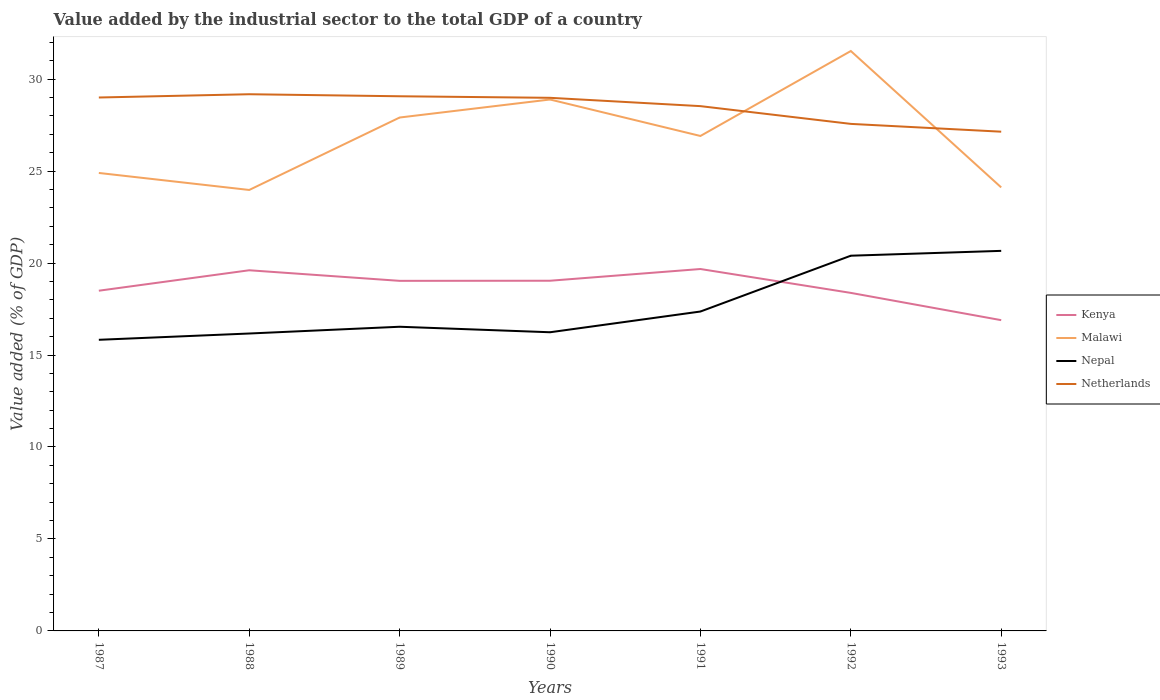How many different coloured lines are there?
Provide a succinct answer. 4. Does the line corresponding to Netherlands intersect with the line corresponding to Kenya?
Offer a terse response. No. Across all years, what is the maximum value added by the industrial sector to the total GDP in Netherlands?
Offer a terse response. 27.14. What is the total value added by the industrial sector to the total GDP in Malawi in the graph?
Provide a succinct answer. 4.78. What is the difference between the highest and the second highest value added by the industrial sector to the total GDP in Kenya?
Provide a succinct answer. 2.78. What is the difference between the highest and the lowest value added by the industrial sector to the total GDP in Netherlands?
Your response must be concise. 5. How many lines are there?
Your answer should be very brief. 4. Are the values on the major ticks of Y-axis written in scientific E-notation?
Make the answer very short. No. Where does the legend appear in the graph?
Offer a terse response. Center right. What is the title of the graph?
Your answer should be compact. Value added by the industrial sector to the total GDP of a country. What is the label or title of the X-axis?
Keep it short and to the point. Years. What is the label or title of the Y-axis?
Offer a very short reply. Value added (% of GDP). What is the Value added (% of GDP) in Kenya in 1987?
Ensure brevity in your answer.  18.49. What is the Value added (% of GDP) of Malawi in 1987?
Offer a terse response. 24.9. What is the Value added (% of GDP) of Nepal in 1987?
Provide a short and direct response. 15.83. What is the Value added (% of GDP) of Netherlands in 1987?
Make the answer very short. 29. What is the Value added (% of GDP) of Kenya in 1988?
Offer a terse response. 19.61. What is the Value added (% of GDP) of Malawi in 1988?
Offer a terse response. 23.97. What is the Value added (% of GDP) of Nepal in 1988?
Ensure brevity in your answer.  16.17. What is the Value added (% of GDP) in Netherlands in 1988?
Provide a short and direct response. 29.18. What is the Value added (% of GDP) in Kenya in 1989?
Your answer should be very brief. 19.03. What is the Value added (% of GDP) in Malawi in 1989?
Ensure brevity in your answer.  27.91. What is the Value added (% of GDP) in Nepal in 1989?
Your response must be concise. 16.54. What is the Value added (% of GDP) of Netherlands in 1989?
Ensure brevity in your answer.  29.07. What is the Value added (% of GDP) in Kenya in 1990?
Offer a very short reply. 19.04. What is the Value added (% of GDP) in Malawi in 1990?
Ensure brevity in your answer.  28.89. What is the Value added (% of GDP) in Nepal in 1990?
Your answer should be very brief. 16.24. What is the Value added (% of GDP) in Netherlands in 1990?
Offer a terse response. 28.98. What is the Value added (% of GDP) in Kenya in 1991?
Your response must be concise. 19.67. What is the Value added (% of GDP) in Malawi in 1991?
Keep it short and to the point. 26.91. What is the Value added (% of GDP) in Nepal in 1991?
Your response must be concise. 17.36. What is the Value added (% of GDP) in Netherlands in 1991?
Ensure brevity in your answer.  28.53. What is the Value added (% of GDP) in Kenya in 1992?
Provide a short and direct response. 18.38. What is the Value added (% of GDP) of Malawi in 1992?
Offer a terse response. 31.53. What is the Value added (% of GDP) in Nepal in 1992?
Your answer should be very brief. 20.4. What is the Value added (% of GDP) in Netherlands in 1992?
Give a very brief answer. 27.56. What is the Value added (% of GDP) of Kenya in 1993?
Provide a succinct answer. 16.89. What is the Value added (% of GDP) in Malawi in 1993?
Your answer should be very brief. 24.11. What is the Value added (% of GDP) in Nepal in 1993?
Provide a short and direct response. 20.66. What is the Value added (% of GDP) of Netherlands in 1993?
Offer a very short reply. 27.14. Across all years, what is the maximum Value added (% of GDP) in Kenya?
Offer a very short reply. 19.67. Across all years, what is the maximum Value added (% of GDP) in Malawi?
Your answer should be very brief. 31.53. Across all years, what is the maximum Value added (% of GDP) of Nepal?
Provide a short and direct response. 20.66. Across all years, what is the maximum Value added (% of GDP) in Netherlands?
Provide a succinct answer. 29.18. Across all years, what is the minimum Value added (% of GDP) in Kenya?
Your response must be concise. 16.89. Across all years, what is the minimum Value added (% of GDP) of Malawi?
Make the answer very short. 23.97. Across all years, what is the minimum Value added (% of GDP) of Nepal?
Provide a short and direct response. 15.83. Across all years, what is the minimum Value added (% of GDP) in Netherlands?
Make the answer very short. 27.14. What is the total Value added (% of GDP) of Kenya in the graph?
Your answer should be very brief. 131.12. What is the total Value added (% of GDP) in Malawi in the graph?
Offer a very short reply. 188.21. What is the total Value added (% of GDP) in Nepal in the graph?
Make the answer very short. 123.19. What is the total Value added (% of GDP) in Netherlands in the graph?
Provide a succinct answer. 199.46. What is the difference between the Value added (% of GDP) of Kenya in 1987 and that in 1988?
Offer a terse response. -1.11. What is the difference between the Value added (% of GDP) of Malawi in 1987 and that in 1988?
Your answer should be very brief. 0.92. What is the difference between the Value added (% of GDP) in Nepal in 1987 and that in 1988?
Offer a terse response. -0.34. What is the difference between the Value added (% of GDP) of Netherlands in 1987 and that in 1988?
Ensure brevity in your answer.  -0.18. What is the difference between the Value added (% of GDP) in Kenya in 1987 and that in 1989?
Provide a succinct answer. -0.54. What is the difference between the Value added (% of GDP) of Malawi in 1987 and that in 1989?
Offer a terse response. -3.01. What is the difference between the Value added (% of GDP) of Nepal in 1987 and that in 1989?
Keep it short and to the point. -0.71. What is the difference between the Value added (% of GDP) in Netherlands in 1987 and that in 1989?
Provide a succinct answer. -0.07. What is the difference between the Value added (% of GDP) of Kenya in 1987 and that in 1990?
Offer a terse response. -0.54. What is the difference between the Value added (% of GDP) in Malawi in 1987 and that in 1990?
Offer a terse response. -3.99. What is the difference between the Value added (% of GDP) in Nepal in 1987 and that in 1990?
Keep it short and to the point. -0.41. What is the difference between the Value added (% of GDP) of Netherlands in 1987 and that in 1990?
Provide a succinct answer. 0.02. What is the difference between the Value added (% of GDP) in Kenya in 1987 and that in 1991?
Your response must be concise. -1.18. What is the difference between the Value added (% of GDP) of Malawi in 1987 and that in 1991?
Keep it short and to the point. -2.01. What is the difference between the Value added (% of GDP) in Nepal in 1987 and that in 1991?
Offer a very short reply. -1.54. What is the difference between the Value added (% of GDP) in Netherlands in 1987 and that in 1991?
Offer a terse response. 0.47. What is the difference between the Value added (% of GDP) of Kenya in 1987 and that in 1992?
Your answer should be compact. 0.12. What is the difference between the Value added (% of GDP) of Malawi in 1987 and that in 1992?
Your answer should be very brief. -6.63. What is the difference between the Value added (% of GDP) of Nepal in 1987 and that in 1992?
Keep it short and to the point. -4.57. What is the difference between the Value added (% of GDP) in Netherlands in 1987 and that in 1992?
Provide a succinct answer. 1.43. What is the difference between the Value added (% of GDP) of Kenya in 1987 and that in 1993?
Give a very brief answer. 1.6. What is the difference between the Value added (% of GDP) in Malawi in 1987 and that in 1993?
Make the answer very short. 0.79. What is the difference between the Value added (% of GDP) of Nepal in 1987 and that in 1993?
Keep it short and to the point. -4.83. What is the difference between the Value added (% of GDP) of Netherlands in 1987 and that in 1993?
Give a very brief answer. 1.86. What is the difference between the Value added (% of GDP) of Kenya in 1988 and that in 1989?
Your response must be concise. 0.58. What is the difference between the Value added (% of GDP) of Malawi in 1988 and that in 1989?
Your answer should be very brief. -3.94. What is the difference between the Value added (% of GDP) in Nepal in 1988 and that in 1989?
Your answer should be very brief. -0.37. What is the difference between the Value added (% of GDP) of Netherlands in 1988 and that in 1989?
Offer a very short reply. 0.11. What is the difference between the Value added (% of GDP) in Kenya in 1988 and that in 1990?
Provide a short and direct response. 0.57. What is the difference between the Value added (% of GDP) in Malawi in 1988 and that in 1990?
Your response must be concise. -4.92. What is the difference between the Value added (% of GDP) of Nepal in 1988 and that in 1990?
Make the answer very short. -0.07. What is the difference between the Value added (% of GDP) in Netherlands in 1988 and that in 1990?
Ensure brevity in your answer.  0.19. What is the difference between the Value added (% of GDP) in Kenya in 1988 and that in 1991?
Provide a short and direct response. -0.07. What is the difference between the Value added (% of GDP) of Malawi in 1988 and that in 1991?
Keep it short and to the point. -2.93. What is the difference between the Value added (% of GDP) of Nepal in 1988 and that in 1991?
Your answer should be compact. -1.19. What is the difference between the Value added (% of GDP) of Netherlands in 1988 and that in 1991?
Ensure brevity in your answer.  0.65. What is the difference between the Value added (% of GDP) of Kenya in 1988 and that in 1992?
Your answer should be very brief. 1.23. What is the difference between the Value added (% of GDP) in Malawi in 1988 and that in 1992?
Make the answer very short. -7.55. What is the difference between the Value added (% of GDP) in Nepal in 1988 and that in 1992?
Offer a terse response. -4.23. What is the difference between the Value added (% of GDP) of Netherlands in 1988 and that in 1992?
Ensure brevity in your answer.  1.61. What is the difference between the Value added (% of GDP) of Kenya in 1988 and that in 1993?
Ensure brevity in your answer.  2.71. What is the difference between the Value added (% of GDP) of Malawi in 1988 and that in 1993?
Your response must be concise. -0.14. What is the difference between the Value added (% of GDP) in Nepal in 1988 and that in 1993?
Your answer should be compact. -4.49. What is the difference between the Value added (% of GDP) in Netherlands in 1988 and that in 1993?
Provide a succinct answer. 2.04. What is the difference between the Value added (% of GDP) in Kenya in 1989 and that in 1990?
Offer a very short reply. -0.01. What is the difference between the Value added (% of GDP) of Malawi in 1989 and that in 1990?
Your answer should be very brief. -0.98. What is the difference between the Value added (% of GDP) of Nepal in 1989 and that in 1990?
Keep it short and to the point. 0.3. What is the difference between the Value added (% of GDP) of Netherlands in 1989 and that in 1990?
Your response must be concise. 0.08. What is the difference between the Value added (% of GDP) of Kenya in 1989 and that in 1991?
Provide a succinct answer. -0.64. What is the difference between the Value added (% of GDP) of Malawi in 1989 and that in 1991?
Offer a terse response. 1. What is the difference between the Value added (% of GDP) of Nepal in 1989 and that in 1991?
Your response must be concise. -0.83. What is the difference between the Value added (% of GDP) of Netherlands in 1989 and that in 1991?
Make the answer very short. 0.54. What is the difference between the Value added (% of GDP) of Kenya in 1989 and that in 1992?
Your answer should be compact. 0.65. What is the difference between the Value added (% of GDP) of Malawi in 1989 and that in 1992?
Make the answer very short. -3.62. What is the difference between the Value added (% of GDP) in Nepal in 1989 and that in 1992?
Provide a succinct answer. -3.86. What is the difference between the Value added (% of GDP) in Netherlands in 1989 and that in 1992?
Offer a very short reply. 1.5. What is the difference between the Value added (% of GDP) of Kenya in 1989 and that in 1993?
Your answer should be very brief. 2.14. What is the difference between the Value added (% of GDP) in Malawi in 1989 and that in 1993?
Offer a terse response. 3.8. What is the difference between the Value added (% of GDP) of Nepal in 1989 and that in 1993?
Provide a short and direct response. -4.13. What is the difference between the Value added (% of GDP) of Netherlands in 1989 and that in 1993?
Provide a short and direct response. 1.93. What is the difference between the Value added (% of GDP) in Kenya in 1990 and that in 1991?
Make the answer very short. -0.64. What is the difference between the Value added (% of GDP) of Malawi in 1990 and that in 1991?
Offer a very short reply. 1.98. What is the difference between the Value added (% of GDP) in Nepal in 1990 and that in 1991?
Provide a short and direct response. -1.13. What is the difference between the Value added (% of GDP) of Netherlands in 1990 and that in 1991?
Your response must be concise. 0.45. What is the difference between the Value added (% of GDP) in Kenya in 1990 and that in 1992?
Provide a succinct answer. 0.66. What is the difference between the Value added (% of GDP) in Malawi in 1990 and that in 1992?
Give a very brief answer. -2.64. What is the difference between the Value added (% of GDP) in Nepal in 1990 and that in 1992?
Keep it short and to the point. -4.16. What is the difference between the Value added (% of GDP) in Netherlands in 1990 and that in 1992?
Your answer should be very brief. 1.42. What is the difference between the Value added (% of GDP) in Kenya in 1990 and that in 1993?
Provide a short and direct response. 2.14. What is the difference between the Value added (% of GDP) in Malawi in 1990 and that in 1993?
Provide a short and direct response. 4.78. What is the difference between the Value added (% of GDP) in Nepal in 1990 and that in 1993?
Keep it short and to the point. -4.42. What is the difference between the Value added (% of GDP) in Netherlands in 1990 and that in 1993?
Provide a succinct answer. 1.84. What is the difference between the Value added (% of GDP) in Kenya in 1991 and that in 1992?
Provide a succinct answer. 1.3. What is the difference between the Value added (% of GDP) in Malawi in 1991 and that in 1992?
Offer a terse response. -4.62. What is the difference between the Value added (% of GDP) in Nepal in 1991 and that in 1992?
Make the answer very short. -3.03. What is the difference between the Value added (% of GDP) of Netherlands in 1991 and that in 1992?
Your answer should be very brief. 0.97. What is the difference between the Value added (% of GDP) of Kenya in 1991 and that in 1993?
Keep it short and to the point. 2.78. What is the difference between the Value added (% of GDP) in Malawi in 1991 and that in 1993?
Your response must be concise. 2.8. What is the difference between the Value added (% of GDP) in Nepal in 1991 and that in 1993?
Make the answer very short. -3.3. What is the difference between the Value added (% of GDP) in Netherlands in 1991 and that in 1993?
Offer a terse response. 1.39. What is the difference between the Value added (% of GDP) in Kenya in 1992 and that in 1993?
Make the answer very short. 1.48. What is the difference between the Value added (% of GDP) of Malawi in 1992 and that in 1993?
Your response must be concise. 7.42. What is the difference between the Value added (% of GDP) in Nepal in 1992 and that in 1993?
Your answer should be compact. -0.26. What is the difference between the Value added (% of GDP) of Netherlands in 1992 and that in 1993?
Make the answer very short. 0.42. What is the difference between the Value added (% of GDP) in Kenya in 1987 and the Value added (% of GDP) in Malawi in 1988?
Offer a very short reply. -5.48. What is the difference between the Value added (% of GDP) in Kenya in 1987 and the Value added (% of GDP) in Nepal in 1988?
Provide a short and direct response. 2.33. What is the difference between the Value added (% of GDP) of Kenya in 1987 and the Value added (% of GDP) of Netherlands in 1988?
Offer a very short reply. -10.68. What is the difference between the Value added (% of GDP) of Malawi in 1987 and the Value added (% of GDP) of Nepal in 1988?
Make the answer very short. 8.73. What is the difference between the Value added (% of GDP) of Malawi in 1987 and the Value added (% of GDP) of Netherlands in 1988?
Provide a succinct answer. -4.28. What is the difference between the Value added (% of GDP) in Nepal in 1987 and the Value added (% of GDP) in Netherlands in 1988?
Your answer should be compact. -13.35. What is the difference between the Value added (% of GDP) of Kenya in 1987 and the Value added (% of GDP) of Malawi in 1989?
Provide a succinct answer. -9.42. What is the difference between the Value added (% of GDP) of Kenya in 1987 and the Value added (% of GDP) of Nepal in 1989?
Your answer should be very brief. 1.96. What is the difference between the Value added (% of GDP) of Kenya in 1987 and the Value added (% of GDP) of Netherlands in 1989?
Offer a very short reply. -10.57. What is the difference between the Value added (% of GDP) of Malawi in 1987 and the Value added (% of GDP) of Nepal in 1989?
Keep it short and to the point. 8.36. What is the difference between the Value added (% of GDP) in Malawi in 1987 and the Value added (% of GDP) in Netherlands in 1989?
Your response must be concise. -4.17. What is the difference between the Value added (% of GDP) of Nepal in 1987 and the Value added (% of GDP) of Netherlands in 1989?
Your answer should be compact. -13.24. What is the difference between the Value added (% of GDP) of Kenya in 1987 and the Value added (% of GDP) of Malawi in 1990?
Your answer should be very brief. -10.4. What is the difference between the Value added (% of GDP) of Kenya in 1987 and the Value added (% of GDP) of Nepal in 1990?
Give a very brief answer. 2.26. What is the difference between the Value added (% of GDP) of Kenya in 1987 and the Value added (% of GDP) of Netherlands in 1990?
Your answer should be very brief. -10.49. What is the difference between the Value added (% of GDP) in Malawi in 1987 and the Value added (% of GDP) in Nepal in 1990?
Give a very brief answer. 8.66. What is the difference between the Value added (% of GDP) in Malawi in 1987 and the Value added (% of GDP) in Netherlands in 1990?
Provide a short and direct response. -4.08. What is the difference between the Value added (% of GDP) in Nepal in 1987 and the Value added (% of GDP) in Netherlands in 1990?
Give a very brief answer. -13.15. What is the difference between the Value added (% of GDP) of Kenya in 1987 and the Value added (% of GDP) of Malawi in 1991?
Offer a very short reply. -8.41. What is the difference between the Value added (% of GDP) of Kenya in 1987 and the Value added (% of GDP) of Nepal in 1991?
Keep it short and to the point. 1.13. What is the difference between the Value added (% of GDP) in Kenya in 1987 and the Value added (% of GDP) in Netherlands in 1991?
Your answer should be compact. -10.03. What is the difference between the Value added (% of GDP) of Malawi in 1987 and the Value added (% of GDP) of Nepal in 1991?
Provide a short and direct response. 7.53. What is the difference between the Value added (% of GDP) in Malawi in 1987 and the Value added (% of GDP) in Netherlands in 1991?
Your answer should be very brief. -3.63. What is the difference between the Value added (% of GDP) in Nepal in 1987 and the Value added (% of GDP) in Netherlands in 1991?
Offer a terse response. -12.7. What is the difference between the Value added (% of GDP) in Kenya in 1987 and the Value added (% of GDP) in Malawi in 1992?
Your answer should be compact. -13.03. What is the difference between the Value added (% of GDP) of Kenya in 1987 and the Value added (% of GDP) of Nepal in 1992?
Offer a very short reply. -1.9. What is the difference between the Value added (% of GDP) of Kenya in 1987 and the Value added (% of GDP) of Netherlands in 1992?
Keep it short and to the point. -9.07. What is the difference between the Value added (% of GDP) in Malawi in 1987 and the Value added (% of GDP) in Nepal in 1992?
Provide a short and direct response. 4.5. What is the difference between the Value added (% of GDP) in Malawi in 1987 and the Value added (% of GDP) in Netherlands in 1992?
Your answer should be very brief. -2.67. What is the difference between the Value added (% of GDP) of Nepal in 1987 and the Value added (% of GDP) of Netherlands in 1992?
Your answer should be compact. -11.74. What is the difference between the Value added (% of GDP) of Kenya in 1987 and the Value added (% of GDP) of Malawi in 1993?
Make the answer very short. -5.62. What is the difference between the Value added (% of GDP) of Kenya in 1987 and the Value added (% of GDP) of Nepal in 1993?
Provide a short and direct response. -2.17. What is the difference between the Value added (% of GDP) of Kenya in 1987 and the Value added (% of GDP) of Netherlands in 1993?
Your response must be concise. -8.65. What is the difference between the Value added (% of GDP) in Malawi in 1987 and the Value added (% of GDP) in Nepal in 1993?
Make the answer very short. 4.24. What is the difference between the Value added (% of GDP) of Malawi in 1987 and the Value added (% of GDP) of Netherlands in 1993?
Your response must be concise. -2.24. What is the difference between the Value added (% of GDP) in Nepal in 1987 and the Value added (% of GDP) in Netherlands in 1993?
Your answer should be compact. -11.31. What is the difference between the Value added (% of GDP) of Kenya in 1988 and the Value added (% of GDP) of Malawi in 1989?
Provide a succinct answer. -8.3. What is the difference between the Value added (% of GDP) in Kenya in 1988 and the Value added (% of GDP) in Nepal in 1989?
Your response must be concise. 3.07. What is the difference between the Value added (% of GDP) in Kenya in 1988 and the Value added (% of GDP) in Netherlands in 1989?
Offer a very short reply. -9.46. What is the difference between the Value added (% of GDP) of Malawi in 1988 and the Value added (% of GDP) of Nepal in 1989?
Your answer should be compact. 7.44. What is the difference between the Value added (% of GDP) of Malawi in 1988 and the Value added (% of GDP) of Netherlands in 1989?
Offer a very short reply. -5.09. What is the difference between the Value added (% of GDP) of Nepal in 1988 and the Value added (% of GDP) of Netherlands in 1989?
Your answer should be compact. -12.9. What is the difference between the Value added (% of GDP) of Kenya in 1988 and the Value added (% of GDP) of Malawi in 1990?
Give a very brief answer. -9.28. What is the difference between the Value added (% of GDP) in Kenya in 1988 and the Value added (% of GDP) in Nepal in 1990?
Keep it short and to the point. 3.37. What is the difference between the Value added (% of GDP) of Kenya in 1988 and the Value added (% of GDP) of Netherlands in 1990?
Ensure brevity in your answer.  -9.38. What is the difference between the Value added (% of GDP) of Malawi in 1988 and the Value added (% of GDP) of Nepal in 1990?
Ensure brevity in your answer.  7.74. What is the difference between the Value added (% of GDP) in Malawi in 1988 and the Value added (% of GDP) in Netherlands in 1990?
Your response must be concise. -5.01. What is the difference between the Value added (% of GDP) in Nepal in 1988 and the Value added (% of GDP) in Netherlands in 1990?
Ensure brevity in your answer.  -12.81. What is the difference between the Value added (% of GDP) in Kenya in 1988 and the Value added (% of GDP) in Malawi in 1991?
Your answer should be very brief. -7.3. What is the difference between the Value added (% of GDP) in Kenya in 1988 and the Value added (% of GDP) in Nepal in 1991?
Give a very brief answer. 2.24. What is the difference between the Value added (% of GDP) of Kenya in 1988 and the Value added (% of GDP) of Netherlands in 1991?
Offer a terse response. -8.92. What is the difference between the Value added (% of GDP) of Malawi in 1988 and the Value added (% of GDP) of Nepal in 1991?
Your answer should be very brief. 6.61. What is the difference between the Value added (% of GDP) of Malawi in 1988 and the Value added (% of GDP) of Netherlands in 1991?
Keep it short and to the point. -4.56. What is the difference between the Value added (% of GDP) of Nepal in 1988 and the Value added (% of GDP) of Netherlands in 1991?
Provide a succinct answer. -12.36. What is the difference between the Value added (% of GDP) in Kenya in 1988 and the Value added (% of GDP) in Malawi in 1992?
Offer a very short reply. -11.92. What is the difference between the Value added (% of GDP) in Kenya in 1988 and the Value added (% of GDP) in Nepal in 1992?
Ensure brevity in your answer.  -0.79. What is the difference between the Value added (% of GDP) in Kenya in 1988 and the Value added (% of GDP) in Netherlands in 1992?
Give a very brief answer. -7.96. What is the difference between the Value added (% of GDP) of Malawi in 1988 and the Value added (% of GDP) of Nepal in 1992?
Your answer should be very brief. 3.57. What is the difference between the Value added (% of GDP) in Malawi in 1988 and the Value added (% of GDP) in Netherlands in 1992?
Your response must be concise. -3.59. What is the difference between the Value added (% of GDP) of Nepal in 1988 and the Value added (% of GDP) of Netherlands in 1992?
Keep it short and to the point. -11.4. What is the difference between the Value added (% of GDP) in Kenya in 1988 and the Value added (% of GDP) in Malawi in 1993?
Make the answer very short. -4.5. What is the difference between the Value added (% of GDP) of Kenya in 1988 and the Value added (% of GDP) of Nepal in 1993?
Your answer should be compact. -1.05. What is the difference between the Value added (% of GDP) in Kenya in 1988 and the Value added (% of GDP) in Netherlands in 1993?
Offer a terse response. -7.53. What is the difference between the Value added (% of GDP) of Malawi in 1988 and the Value added (% of GDP) of Nepal in 1993?
Your answer should be very brief. 3.31. What is the difference between the Value added (% of GDP) of Malawi in 1988 and the Value added (% of GDP) of Netherlands in 1993?
Offer a terse response. -3.17. What is the difference between the Value added (% of GDP) of Nepal in 1988 and the Value added (% of GDP) of Netherlands in 1993?
Make the answer very short. -10.97. What is the difference between the Value added (% of GDP) in Kenya in 1989 and the Value added (% of GDP) in Malawi in 1990?
Provide a succinct answer. -9.86. What is the difference between the Value added (% of GDP) in Kenya in 1989 and the Value added (% of GDP) in Nepal in 1990?
Keep it short and to the point. 2.79. What is the difference between the Value added (% of GDP) in Kenya in 1989 and the Value added (% of GDP) in Netherlands in 1990?
Your answer should be very brief. -9.95. What is the difference between the Value added (% of GDP) of Malawi in 1989 and the Value added (% of GDP) of Nepal in 1990?
Provide a succinct answer. 11.67. What is the difference between the Value added (% of GDP) in Malawi in 1989 and the Value added (% of GDP) in Netherlands in 1990?
Keep it short and to the point. -1.07. What is the difference between the Value added (% of GDP) in Nepal in 1989 and the Value added (% of GDP) in Netherlands in 1990?
Ensure brevity in your answer.  -12.45. What is the difference between the Value added (% of GDP) of Kenya in 1989 and the Value added (% of GDP) of Malawi in 1991?
Make the answer very short. -7.88. What is the difference between the Value added (% of GDP) of Kenya in 1989 and the Value added (% of GDP) of Nepal in 1991?
Ensure brevity in your answer.  1.67. What is the difference between the Value added (% of GDP) of Kenya in 1989 and the Value added (% of GDP) of Netherlands in 1991?
Give a very brief answer. -9.5. What is the difference between the Value added (% of GDP) of Malawi in 1989 and the Value added (% of GDP) of Nepal in 1991?
Your answer should be very brief. 10.55. What is the difference between the Value added (% of GDP) in Malawi in 1989 and the Value added (% of GDP) in Netherlands in 1991?
Give a very brief answer. -0.62. What is the difference between the Value added (% of GDP) in Nepal in 1989 and the Value added (% of GDP) in Netherlands in 1991?
Make the answer very short. -11.99. What is the difference between the Value added (% of GDP) of Kenya in 1989 and the Value added (% of GDP) of Malawi in 1992?
Keep it short and to the point. -12.49. What is the difference between the Value added (% of GDP) in Kenya in 1989 and the Value added (% of GDP) in Nepal in 1992?
Provide a short and direct response. -1.37. What is the difference between the Value added (% of GDP) of Kenya in 1989 and the Value added (% of GDP) of Netherlands in 1992?
Keep it short and to the point. -8.53. What is the difference between the Value added (% of GDP) in Malawi in 1989 and the Value added (% of GDP) in Nepal in 1992?
Offer a terse response. 7.51. What is the difference between the Value added (% of GDP) in Malawi in 1989 and the Value added (% of GDP) in Netherlands in 1992?
Provide a short and direct response. 0.35. What is the difference between the Value added (% of GDP) of Nepal in 1989 and the Value added (% of GDP) of Netherlands in 1992?
Offer a terse response. -11.03. What is the difference between the Value added (% of GDP) of Kenya in 1989 and the Value added (% of GDP) of Malawi in 1993?
Keep it short and to the point. -5.08. What is the difference between the Value added (% of GDP) of Kenya in 1989 and the Value added (% of GDP) of Nepal in 1993?
Your answer should be very brief. -1.63. What is the difference between the Value added (% of GDP) of Kenya in 1989 and the Value added (% of GDP) of Netherlands in 1993?
Give a very brief answer. -8.11. What is the difference between the Value added (% of GDP) in Malawi in 1989 and the Value added (% of GDP) in Nepal in 1993?
Provide a succinct answer. 7.25. What is the difference between the Value added (% of GDP) of Malawi in 1989 and the Value added (% of GDP) of Netherlands in 1993?
Offer a terse response. 0.77. What is the difference between the Value added (% of GDP) in Nepal in 1989 and the Value added (% of GDP) in Netherlands in 1993?
Your response must be concise. -10.6. What is the difference between the Value added (% of GDP) in Kenya in 1990 and the Value added (% of GDP) in Malawi in 1991?
Your response must be concise. -7.87. What is the difference between the Value added (% of GDP) of Kenya in 1990 and the Value added (% of GDP) of Nepal in 1991?
Your answer should be very brief. 1.67. What is the difference between the Value added (% of GDP) in Kenya in 1990 and the Value added (% of GDP) in Netherlands in 1991?
Ensure brevity in your answer.  -9.49. What is the difference between the Value added (% of GDP) of Malawi in 1990 and the Value added (% of GDP) of Nepal in 1991?
Your answer should be compact. 11.53. What is the difference between the Value added (% of GDP) of Malawi in 1990 and the Value added (% of GDP) of Netherlands in 1991?
Keep it short and to the point. 0.36. What is the difference between the Value added (% of GDP) in Nepal in 1990 and the Value added (% of GDP) in Netherlands in 1991?
Make the answer very short. -12.29. What is the difference between the Value added (% of GDP) of Kenya in 1990 and the Value added (% of GDP) of Malawi in 1992?
Offer a terse response. -12.49. What is the difference between the Value added (% of GDP) of Kenya in 1990 and the Value added (% of GDP) of Nepal in 1992?
Make the answer very short. -1.36. What is the difference between the Value added (% of GDP) in Kenya in 1990 and the Value added (% of GDP) in Netherlands in 1992?
Make the answer very short. -8.53. What is the difference between the Value added (% of GDP) of Malawi in 1990 and the Value added (% of GDP) of Nepal in 1992?
Keep it short and to the point. 8.49. What is the difference between the Value added (% of GDP) of Malawi in 1990 and the Value added (% of GDP) of Netherlands in 1992?
Provide a succinct answer. 1.33. What is the difference between the Value added (% of GDP) of Nepal in 1990 and the Value added (% of GDP) of Netherlands in 1992?
Your answer should be very brief. -11.33. What is the difference between the Value added (% of GDP) in Kenya in 1990 and the Value added (% of GDP) in Malawi in 1993?
Ensure brevity in your answer.  -5.07. What is the difference between the Value added (% of GDP) of Kenya in 1990 and the Value added (% of GDP) of Nepal in 1993?
Keep it short and to the point. -1.62. What is the difference between the Value added (% of GDP) in Kenya in 1990 and the Value added (% of GDP) in Netherlands in 1993?
Give a very brief answer. -8.1. What is the difference between the Value added (% of GDP) in Malawi in 1990 and the Value added (% of GDP) in Nepal in 1993?
Your answer should be compact. 8.23. What is the difference between the Value added (% of GDP) of Malawi in 1990 and the Value added (% of GDP) of Netherlands in 1993?
Make the answer very short. 1.75. What is the difference between the Value added (% of GDP) in Nepal in 1990 and the Value added (% of GDP) in Netherlands in 1993?
Ensure brevity in your answer.  -10.9. What is the difference between the Value added (% of GDP) in Kenya in 1991 and the Value added (% of GDP) in Malawi in 1992?
Keep it short and to the point. -11.85. What is the difference between the Value added (% of GDP) in Kenya in 1991 and the Value added (% of GDP) in Nepal in 1992?
Your answer should be very brief. -0.72. What is the difference between the Value added (% of GDP) of Kenya in 1991 and the Value added (% of GDP) of Netherlands in 1992?
Your answer should be very brief. -7.89. What is the difference between the Value added (% of GDP) of Malawi in 1991 and the Value added (% of GDP) of Nepal in 1992?
Give a very brief answer. 6.51. What is the difference between the Value added (% of GDP) in Malawi in 1991 and the Value added (% of GDP) in Netherlands in 1992?
Your response must be concise. -0.66. What is the difference between the Value added (% of GDP) in Nepal in 1991 and the Value added (% of GDP) in Netherlands in 1992?
Your answer should be very brief. -10.2. What is the difference between the Value added (% of GDP) in Kenya in 1991 and the Value added (% of GDP) in Malawi in 1993?
Your answer should be very brief. -4.44. What is the difference between the Value added (% of GDP) of Kenya in 1991 and the Value added (% of GDP) of Nepal in 1993?
Provide a short and direct response. -0.99. What is the difference between the Value added (% of GDP) of Kenya in 1991 and the Value added (% of GDP) of Netherlands in 1993?
Make the answer very short. -7.47. What is the difference between the Value added (% of GDP) in Malawi in 1991 and the Value added (% of GDP) in Nepal in 1993?
Keep it short and to the point. 6.25. What is the difference between the Value added (% of GDP) in Malawi in 1991 and the Value added (% of GDP) in Netherlands in 1993?
Your response must be concise. -0.23. What is the difference between the Value added (% of GDP) of Nepal in 1991 and the Value added (% of GDP) of Netherlands in 1993?
Your answer should be compact. -9.78. What is the difference between the Value added (% of GDP) in Kenya in 1992 and the Value added (% of GDP) in Malawi in 1993?
Keep it short and to the point. -5.73. What is the difference between the Value added (% of GDP) in Kenya in 1992 and the Value added (% of GDP) in Nepal in 1993?
Provide a succinct answer. -2.28. What is the difference between the Value added (% of GDP) of Kenya in 1992 and the Value added (% of GDP) of Netherlands in 1993?
Make the answer very short. -8.76. What is the difference between the Value added (% of GDP) in Malawi in 1992 and the Value added (% of GDP) in Nepal in 1993?
Provide a short and direct response. 10.86. What is the difference between the Value added (% of GDP) in Malawi in 1992 and the Value added (% of GDP) in Netherlands in 1993?
Provide a short and direct response. 4.39. What is the difference between the Value added (% of GDP) in Nepal in 1992 and the Value added (% of GDP) in Netherlands in 1993?
Keep it short and to the point. -6.74. What is the average Value added (% of GDP) in Kenya per year?
Make the answer very short. 18.73. What is the average Value added (% of GDP) of Malawi per year?
Provide a short and direct response. 26.89. What is the average Value added (% of GDP) in Nepal per year?
Provide a short and direct response. 17.6. What is the average Value added (% of GDP) of Netherlands per year?
Provide a succinct answer. 28.49. In the year 1987, what is the difference between the Value added (% of GDP) in Kenya and Value added (% of GDP) in Malawi?
Your answer should be very brief. -6.4. In the year 1987, what is the difference between the Value added (% of GDP) of Kenya and Value added (% of GDP) of Nepal?
Keep it short and to the point. 2.67. In the year 1987, what is the difference between the Value added (% of GDP) of Kenya and Value added (% of GDP) of Netherlands?
Your response must be concise. -10.5. In the year 1987, what is the difference between the Value added (% of GDP) in Malawi and Value added (% of GDP) in Nepal?
Offer a very short reply. 9.07. In the year 1987, what is the difference between the Value added (% of GDP) in Malawi and Value added (% of GDP) in Netherlands?
Make the answer very short. -4.1. In the year 1987, what is the difference between the Value added (% of GDP) in Nepal and Value added (% of GDP) in Netherlands?
Keep it short and to the point. -13.17. In the year 1988, what is the difference between the Value added (% of GDP) of Kenya and Value added (% of GDP) of Malawi?
Your response must be concise. -4.37. In the year 1988, what is the difference between the Value added (% of GDP) of Kenya and Value added (% of GDP) of Nepal?
Your answer should be very brief. 3.44. In the year 1988, what is the difference between the Value added (% of GDP) in Kenya and Value added (% of GDP) in Netherlands?
Your answer should be very brief. -9.57. In the year 1988, what is the difference between the Value added (% of GDP) of Malawi and Value added (% of GDP) of Nepal?
Your response must be concise. 7.8. In the year 1988, what is the difference between the Value added (% of GDP) in Malawi and Value added (% of GDP) in Netherlands?
Provide a short and direct response. -5.2. In the year 1988, what is the difference between the Value added (% of GDP) of Nepal and Value added (% of GDP) of Netherlands?
Keep it short and to the point. -13.01. In the year 1989, what is the difference between the Value added (% of GDP) of Kenya and Value added (% of GDP) of Malawi?
Your answer should be very brief. -8.88. In the year 1989, what is the difference between the Value added (% of GDP) of Kenya and Value added (% of GDP) of Nepal?
Give a very brief answer. 2.5. In the year 1989, what is the difference between the Value added (% of GDP) of Kenya and Value added (% of GDP) of Netherlands?
Offer a very short reply. -10.03. In the year 1989, what is the difference between the Value added (% of GDP) of Malawi and Value added (% of GDP) of Nepal?
Your response must be concise. 11.37. In the year 1989, what is the difference between the Value added (% of GDP) of Malawi and Value added (% of GDP) of Netherlands?
Your answer should be very brief. -1.16. In the year 1989, what is the difference between the Value added (% of GDP) in Nepal and Value added (% of GDP) in Netherlands?
Make the answer very short. -12.53. In the year 1990, what is the difference between the Value added (% of GDP) in Kenya and Value added (% of GDP) in Malawi?
Offer a terse response. -9.85. In the year 1990, what is the difference between the Value added (% of GDP) of Kenya and Value added (% of GDP) of Nepal?
Give a very brief answer. 2.8. In the year 1990, what is the difference between the Value added (% of GDP) in Kenya and Value added (% of GDP) in Netherlands?
Make the answer very short. -9.94. In the year 1990, what is the difference between the Value added (% of GDP) of Malawi and Value added (% of GDP) of Nepal?
Make the answer very short. 12.65. In the year 1990, what is the difference between the Value added (% of GDP) in Malawi and Value added (% of GDP) in Netherlands?
Offer a terse response. -0.09. In the year 1990, what is the difference between the Value added (% of GDP) of Nepal and Value added (% of GDP) of Netherlands?
Offer a very short reply. -12.74. In the year 1991, what is the difference between the Value added (% of GDP) in Kenya and Value added (% of GDP) in Malawi?
Make the answer very short. -7.23. In the year 1991, what is the difference between the Value added (% of GDP) of Kenya and Value added (% of GDP) of Nepal?
Provide a short and direct response. 2.31. In the year 1991, what is the difference between the Value added (% of GDP) of Kenya and Value added (% of GDP) of Netherlands?
Your answer should be compact. -8.86. In the year 1991, what is the difference between the Value added (% of GDP) of Malawi and Value added (% of GDP) of Nepal?
Your answer should be very brief. 9.54. In the year 1991, what is the difference between the Value added (% of GDP) in Malawi and Value added (% of GDP) in Netherlands?
Make the answer very short. -1.62. In the year 1991, what is the difference between the Value added (% of GDP) in Nepal and Value added (% of GDP) in Netherlands?
Your response must be concise. -11.17. In the year 1992, what is the difference between the Value added (% of GDP) of Kenya and Value added (% of GDP) of Malawi?
Offer a very short reply. -13.15. In the year 1992, what is the difference between the Value added (% of GDP) in Kenya and Value added (% of GDP) in Nepal?
Offer a very short reply. -2.02. In the year 1992, what is the difference between the Value added (% of GDP) of Kenya and Value added (% of GDP) of Netherlands?
Provide a short and direct response. -9.19. In the year 1992, what is the difference between the Value added (% of GDP) of Malawi and Value added (% of GDP) of Nepal?
Provide a succinct answer. 11.13. In the year 1992, what is the difference between the Value added (% of GDP) of Malawi and Value added (% of GDP) of Netherlands?
Your answer should be very brief. 3.96. In the year 1992, what is the difference between the Value added (% of GDP) in Nepal and Value added (% of GDP) in Netherlands?
Provide a short and direct response. -7.17. In the year 1993, what is the difference between the Value added (% of GDP) of Kenya and Value added (% of GDP) of Malawi?
Your answer should be very brief. -7.22. In the year 1993, what is the difference between the Value added (% of GDP) in Kenya and Value added (% of GDP) in Nepal?
Your answer should be very brief. -3.77. In the year 1993, what is the difference between the Value added (% of GDP) in Kenya and Value added (% of GDP) in Netherlands?
Offer a terse response. -10.25. In the year 1993, what is the difference between the Value added (% of GDP) in Malawi and Value added (% of GDP) in Nepal?
Keep it short and to the point. 3.45. In the year 1993, what is the difference between the Value added (% of GDP) in Malawi and Value added (% of GDP) in Netherlands?
Offer a terse response. -3.03. In the year 1993, what is the difference between the Value added (% of GDP) of Nepal and Value added (% of GDP) of Netherlands?
Your answer should be very brief. -6.48. What is the ratio of the Value added (% of GDP) in Kenya in 1987 to that in 1988?
Provide a succinct answer. 0.94. What is the ratio of the Value added (% of GDP) in Malawi in 1987 to that in 1988?
Your answer should be compact. 1.04. What is the ratio of the Value added (% of GDP) in Nepal in 1987 to that in 1988?
Keep it short and to the point. 0.98. What is the ratio of the Value added (% of GDP) of Kenya in 1987 to that in 1989?
Your response must be concise. 0.97. What is the ratio of the Value added (% of GDP) of Malawi in 1987 to that in 1989?
Make the answer very short. 0.89. What is the ratio of the Value added (% of GDP) in Nepal in 1987 to that in 1989?
Provide a succinct answer. 0.96. What is the ratio of the Value added (% of GDP) in Netherlands in 1987 to that in 1989?
Your response must be concise. 1. What is the ratio of the Value added (% of GDP) in Kenya in 1987 to that in 1990?
Ensure brevity in your answer.  0.97. What is the ratio of the Value added (% of GDP) in Malawi in 1987 to that in 1990?
Your response must be concise. 0.86. What is the ratio of the Value added (% of GDP) of Nepal in 1987 to that in 1990?
Keep it short and to the point. 0.97. What is the ratio of the Value added (% of GDP) in Netherlands in 1987 to that in 1990?
Your answer should be very brief. 1. What is the ratio of the Value added (% of GDP) in Malawi in 1987 to that in 1991?
Make the answer very short. 0.93. What is the ratio of the Value added (% of GDP) of Nepal in 1987 to that in 1991?
Offer a terse response. 0.91. What is the ratio of the Value added (% of GDP) of Netherlands in 1987 to that in 1991?
Offer a terse response. 1.02. What is the ratio of the Value added (% of GDP) in Kenya in 1987 to that in 1992?
Give a very brief answer. 1.01. What is the ratio of the Value added (% of GDP) in Malawi in 1987 to that in 1992?
Ensure brevity in your answer.  0.79. What is the ratio of the Value added (% of GDP) of Nepal in 1987 to that in 1992?
Offer a very short reply. 0.78. What is the ratio of the Value added (% of GDP) of Netherlands in 1987 to that in 1992?
Keep it short and to the point. 1.05. What is the ratio of the Value added (% of GDP) of Kenya in 1987 to that in 1993?
Your answer should be very brief. 1.09. What is the ratio of the Value added (% of GDP) in Malawi in 1987 to that in 1993?
Ensure brevity in your answer.  1.03. What is the ratio of the Value added (% of GDP) in Nepal in 1987 to that in 1993?
Offer a very short reply. 0.77. What is the ratio of the Value added (% of GDP) of Netherlands in 1987 to that in 1993?
Ensure brevity in your answer.  1.07. What is the ratio of the Value added (% of GDP) of Kenya in 1988 to that in 1989?
Offer a terse response. 1.03. What is the ratio of the Value added (% of GDP) of Malawi in 1988 to that in 1989?
Your response must be concise. 0.86. What is the ratio of the Value added (% of GDP) of Nepal in 1988 to that in 1989?
Make the answer very short. 0.98. What is the ratio of the Value added (% of GDP) in Kenya in 1988 to that in 1990?
Provide a short and direct response. 1.03. What is the ratio of the Value added (% of GDP) of Malawi in 1988 to that in 1990?
Provide a short and direct response. 0.83. What is the ratio of the Value added (% of GDP) in Nepal in 1988 to that in 1990?
Provide a succinct answer. 1. What is the ratio of the Value added (% of GDP) in Netherlands in 1988 to that in 1990?
Make the answer very short. 1.01. What is the ratio of the Value added (% of GDP) in Malawi in 1988 to that in 1991?
Your answer should be compact. 0.89. What is the ratio of the Value added (% of GDP) in Nepal in 1988 to that in 1991?
Keep it short and to the point. 0.93. What is the ratio of the Value added (% of GDP) of Netherlands in 1988 to that in 1991?
Give a very brief answer. 1.02. What is the ratio of the Value added (% of GDP) in Kenya in 1988 to that in 1992?
Offer a terse response. 1.07. What is the ratio of the Value added (% of GDP) of Malawi in 1988 to that in 1992?
Keep it short and to the point. 0.76. What is the ratio of the Value added (% of GDP) of Nepal in 1988 to that in 1992?
Offer a very short reply. 0.79. What is the ratio of the Value added (% of GDP) in Netherlands in 1988 to that in 1992?
Provide a short and direct response. 1.06. What is the ratio of the Value added (% of GDP) in Kenya in 1988 to that in 1993?
Ensure brevity in your answer.  1.16. What is the ratio of the Value added (% of GDP) in Nepal in 1988 to that in 1993?
Offer a very short reply. 0.78. What is the ratio of the Value added (% of GDP) of Netherlands in 1988 to that in 1993?
Make the answer very short. 1.07. What is the ratio of the Value added (% of GDP) of Kenya in 1989 to that in 1990?
Provide a short and direct response. 1. What is the ratio of the Value added (% of GDP) of Malawi in 1989 to that in 1990?
Offer a very short reply. 0.97. What is the ratio of the Value added (% of GDP) of Nepal in 1989 to that in 1990?
Keep it short and to the point. 1.02. What is the ratio of the Value added (% of GDP) in Netherlands in 1989 to that in 1990?
Make the answer very short. 1. What is the ratio of the Value added (% of GDP) of Kenya in 1989 to that in 1991?
Keep it short and to the point. 0.97. What is the ratio of the Value added (% of GDP) of Malawi in 1989 to that in 1991?
Your answer should be very brief. 1.04. What is the ratio of the Value added (% of GDP) in Netherlands in 1989 to that in 1991?
Make the answer very short. 1.02. What is the ratio of the Value added (% of GDP) in Kenya in 1989 to that in 1992?
Give a very brief answer. 1.04. What is the ratio of the Value added (% of GDP) in Malawi in 1989 to that in 1992?
Provide a succinct answer. 0.89. What is the ratio of the Value added (% of GDP) in Nepal in 1989 to that in 1992?
Keep it short and to the point. 0.81. What is the ratio of the Value added (% of GDP) in Netherlands in 1989 to that in 1992?
Make the answer very short. 1.05. What is the ratio of the Value added (% of GDP) in Kenya in 1989 to that in 1993?
Keep it short and to the point. 1.13. What is the ratio of the Value added (% of GDP) of Malawi in 1989 to that in 1993?
Ensure brevity in your answer.  1.16. What is the ratio of the Value added (% of GDP) in Nepal in 1989 to that in 1993?
Offer a terse response. 0.8. What is the ratio of the Value added (% of GDP) of Netherlands in 1989 to that in 1993?
Keep it short and to the point. 1.07. What is the ratio of the Value added (% of GDP) of Kenya in 1990 to that in 1991?
Make the answer very short. 0.97. What is the ratio of the Value added (% of GDP) in Malawi in 1990 to that in 1991?
Offer a very short reply. 1.07. What is the ratio of the Value added (% of GDP) in Nepal in 1990 to that in 1991?
Make the answer very short. 0.94. What is the ratio of the Value added (% of GDP) in Netherlands in 1990 to that in 1991?
Provide a succinct answer. 1.02. What is the ratio of the Value added (% of GDP) in Kenya in 1990 to that in 1992?
Your answer should be very brief. 1.04. What is the ratio of the Value added (% of GDP) of Malawi in 1990 to that in 1992?
Make the answer very short. 0.92. What is the ratio of the Value added (% of GDP) of Nepal in 1990 to that in 1992?
Make the answer very short. 0.8. What is the ratio of the Value added (% of GDP) of Netherlands in 1990 to that in 1992?
Your answer should be compact. 1.05. What is the ratio of the Value added (% of GDP) of Kenya in 1990 to that in 1993?
Your answer should be compact. 1.13. What is the ratio of the Value added (% of GDP) in Malawi in 1990 to that in 1993?
Offer a terse response. 1.2. What is the ratio of the Value added (% of GDP) in Nepal in 1990 to that in 1993?
Give a very brief answer. 0.79. What is the ratio of the Value added (% of GDP) of Netherlands in 1990 to that in 1993?
Keep it short and to the point. 1.07. What is the ratio of the Value added (% of GDP) of Kenya in 1991 to that in 1992?
Offer a very short reply. 1.07. What is the ratio of the Value added (% of GDP) in Malawi in 1991 to that in 1992?
Provide a succinct answer. 0.85. What is the ratio of the Value added (% of GDP) of Nepal in 1991 to that in 1992?
Offer a terse response. 0.85. What is the ratio of the Value added (% of GDP) in Netherlands in 1991 to that in 1992?
Offer a very short reply. 1.03. What is the ratio of the Value added (% of GDP) of Kenya in 1991 to that in 1993?
Offer a very short reply. 1.16. What is the ratio of the Value added (% of GDP) of Malawi in 1991 to that in 1993?
Offer a terse response. 1.12. What is the ratio of the Value added (% of GDP) of Nepal in 1991 to that in 1993?
Offer a very short reply. 0.84. What is the ratio of the Value added (% of GDP) in Netherlands in 1991 to that in 1993?
Your response must be concise. 1.05. What is the ratio of the Value added (% of GDP) in Kenya in 1992 to that in 1993?
Your response must be concise. 1.09. What is the ratio of the Value added (% of GDP) of Malawi in 1992 to that in 1993?
Provide a succinct answer. 1.31. What is the ratio of the Value added (% of GDP) in Nepal in 1992 to that in 1993?
Offer a very short reply. 0.99. What is the ratio of the Value added (% of GDP) of Netherlands in 1992 to that in 1993?
Provide a succinct answer. 1.02. What is the difference between the highest and the second highest Value added (% of GDP) of Kenya?
Offer a terse response. 0.07. What is the difference between the highest and the second highest Value added (% of GDP) of Malawi?
Give a very brief answer. 2.64. What is the difference between the highest and the second highest Value added (% of GDP) of Nepal?
Make the answer very short. 0.26. What is the difference between the highest and the second highest Value added (% of GDP) in Netherlands?
Provide a short and direct response. 0.11. What is the difference between the highest and the lowest Value added (% of GDP) of Kenya?
Offer a very short reply. 2.78. What is the difference between the highest and the lowest Value added (% of GDP) in Malawi?
Give a very brief answer. 7.55. What is the difference between the highest and the lowest Value added (% of GDP) in Nepal?
Your response must be concise. 4.83. What is the difference between the highest and the lowest Value added (% of GDP) in Netherlands?
Make the answer very short. 2.04. 